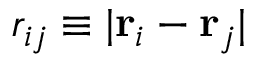<formula> <loc_0><loc_0><loc_500><loc_500>r _ { i j } \equiv | { r } _ { i } - { r } _ { j } |</formula> 